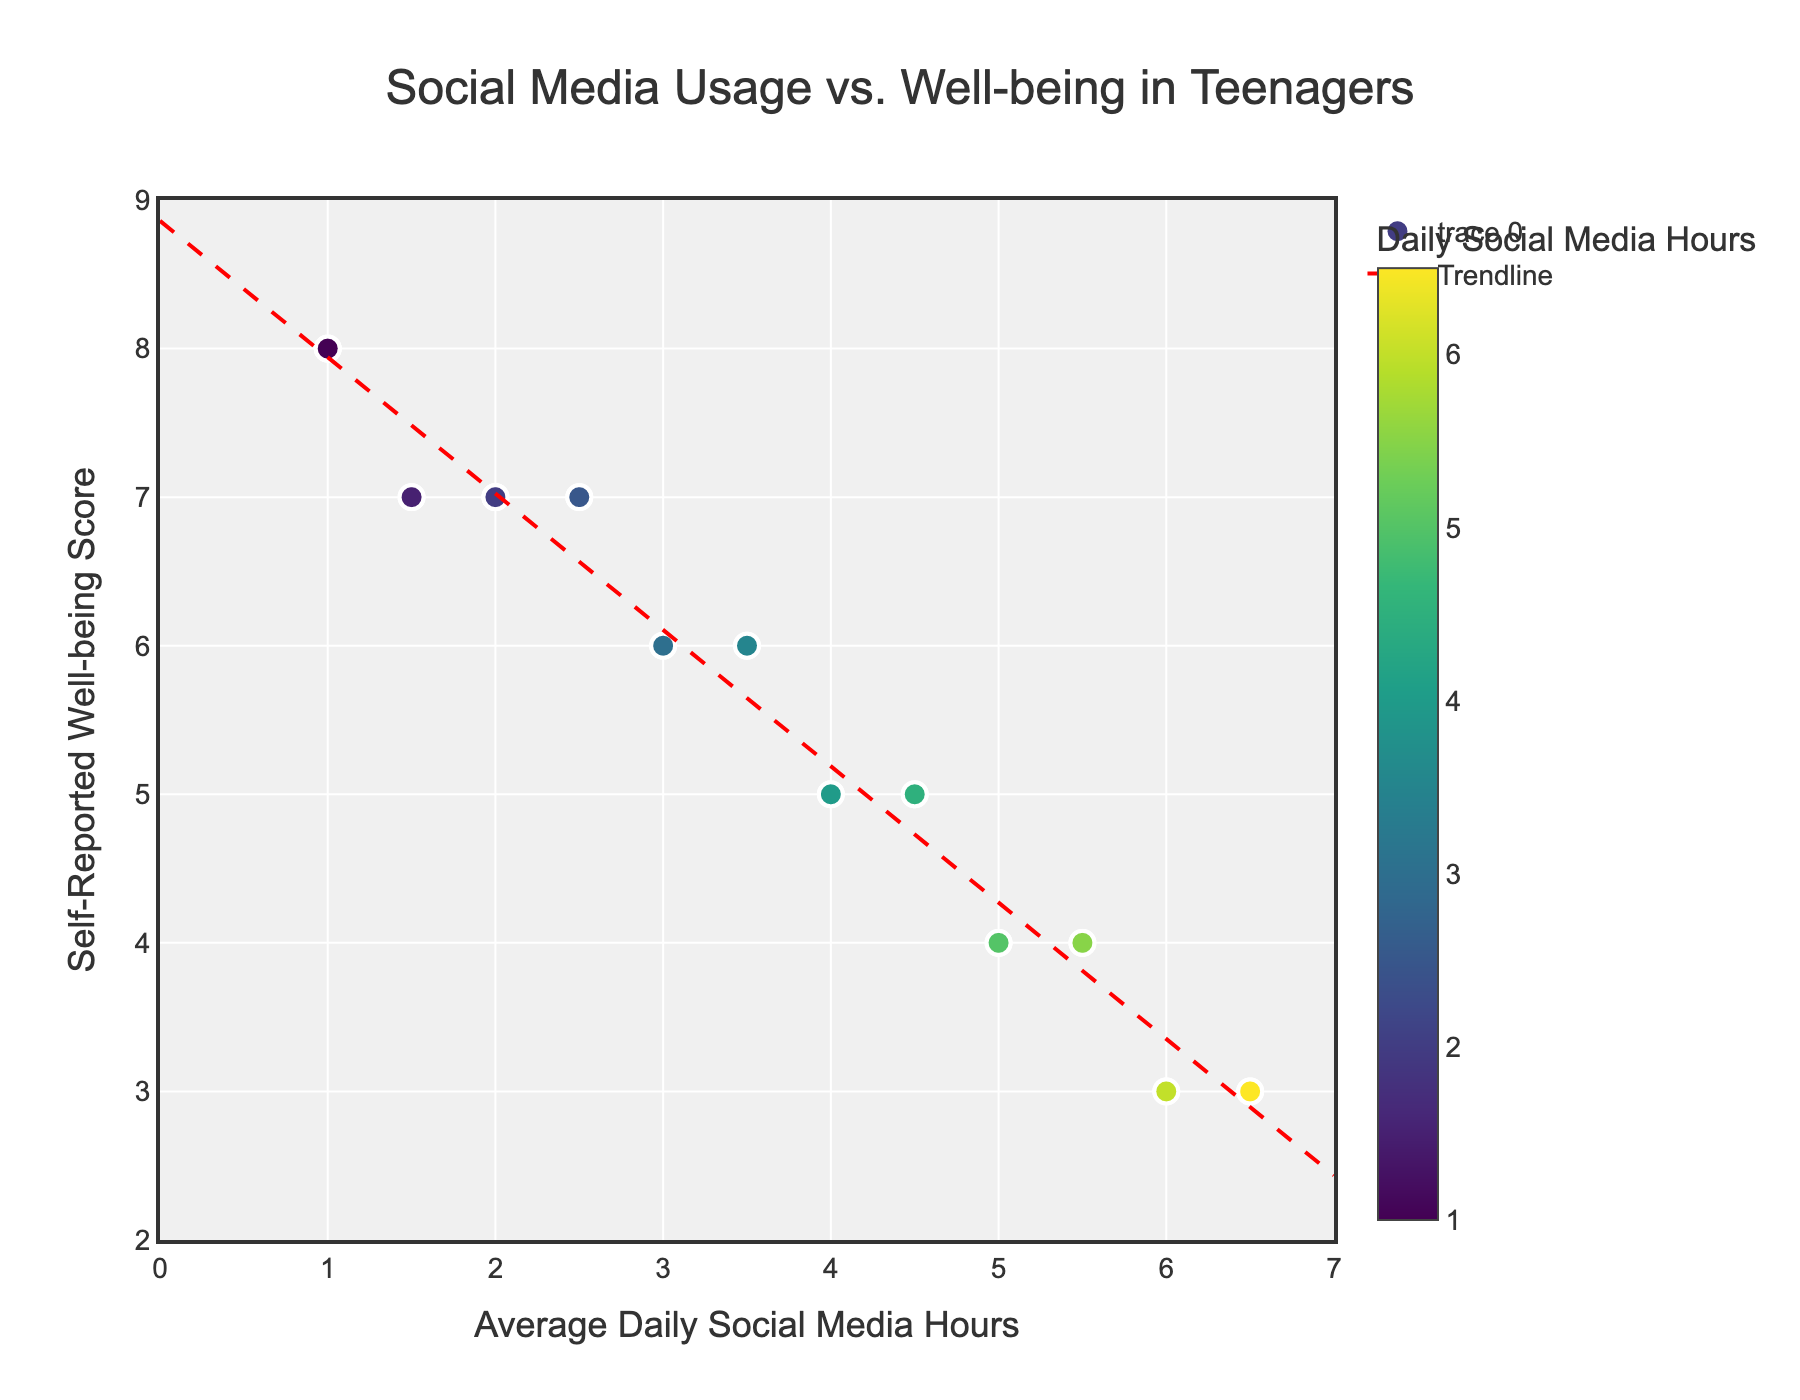What is the title of the figure? The title is located at the top of the figure. It usually summarizes what the figure is about.
Answer: Social Media Usage vs. Well-being in Teenagers What are the labels of the x-axis and y-axis? The labels are found along the respective axes and denote what each axis represents. The x-axis label is below the horizontal line, while the y-axis label is next to the vertical line.
Answer: Average Daily Social Media Hours, Self-Reported Well-being Score Which participant has the highest average daily social media usage? Look for the data point that is furthest to the right to identify the participant with the highest x-value.
Answer: Luke and Xena Which participant has the lowest self-reported well-being score? Find the data point that is lowest on the y-axis to identify the participant with the lowest y-value.
Answer: Frank, Luke, Rita, Xena How many participants have an average daily social media usage of more than 5 hours? Count the number of data points that are located to the right of the 5-hour mark on the x-axis.
Answer: 6 What is the trendline's direction between social media usage and well-being? Observe the general slope of the red dashed trendline to determine whether it is increasing, decreasing, or neutral.
Answer: Decreasing What participant has an average daily social media usage of 1 hour and a high well-being score? Identify the data point located at around 1 on the x-axis and check its y-value for the highest score.
Answer: David, Mia, Yara Compare the well-being scores of participants with 2 hours versus 6 hours average daily social media usage. Find the data points corresponding to 2 hours and 6 hours on the x-axis and compare their y-values for the well-being scores.
Answer: Higher with 2 hours What is the most common well-being score for participants averaging between 3 and 4 hours daily social media usage? Select data points within the range of 3 to 4 on the x-axis and identify which y-value appears most frequently.
Answer: 6 Which participant averages more than 4.5 hours of social media usage but has a well-being score of exactly 5? Identify data points with x-values greater than 4.5 and y-values equal to 5 and look at their labels.
Answer: Ivy, Vera 